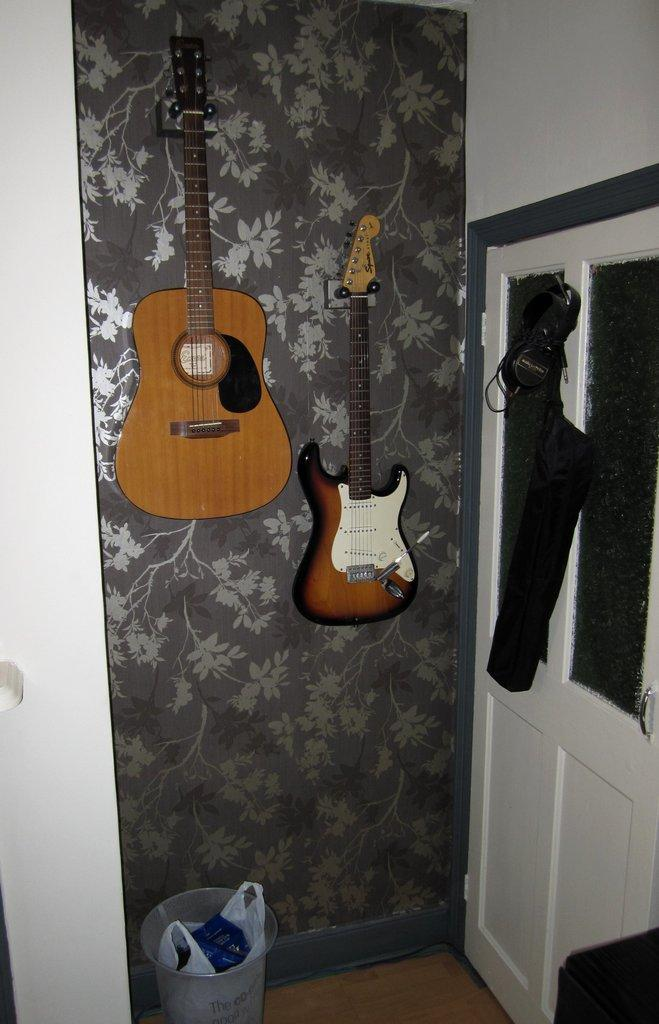How many guitars are on the table in the image? There are 2 guitars on the table in the image. What other object can be seen in the image besides the guitars? There is a dustbin in the image. Can you identify any architectural features in the image? Yes, there is a door in the image. What type of distribution system is visible in the image? There is no distribution system present in the image. Can you see a bridge in the image? There is no bridge visible in the image. 